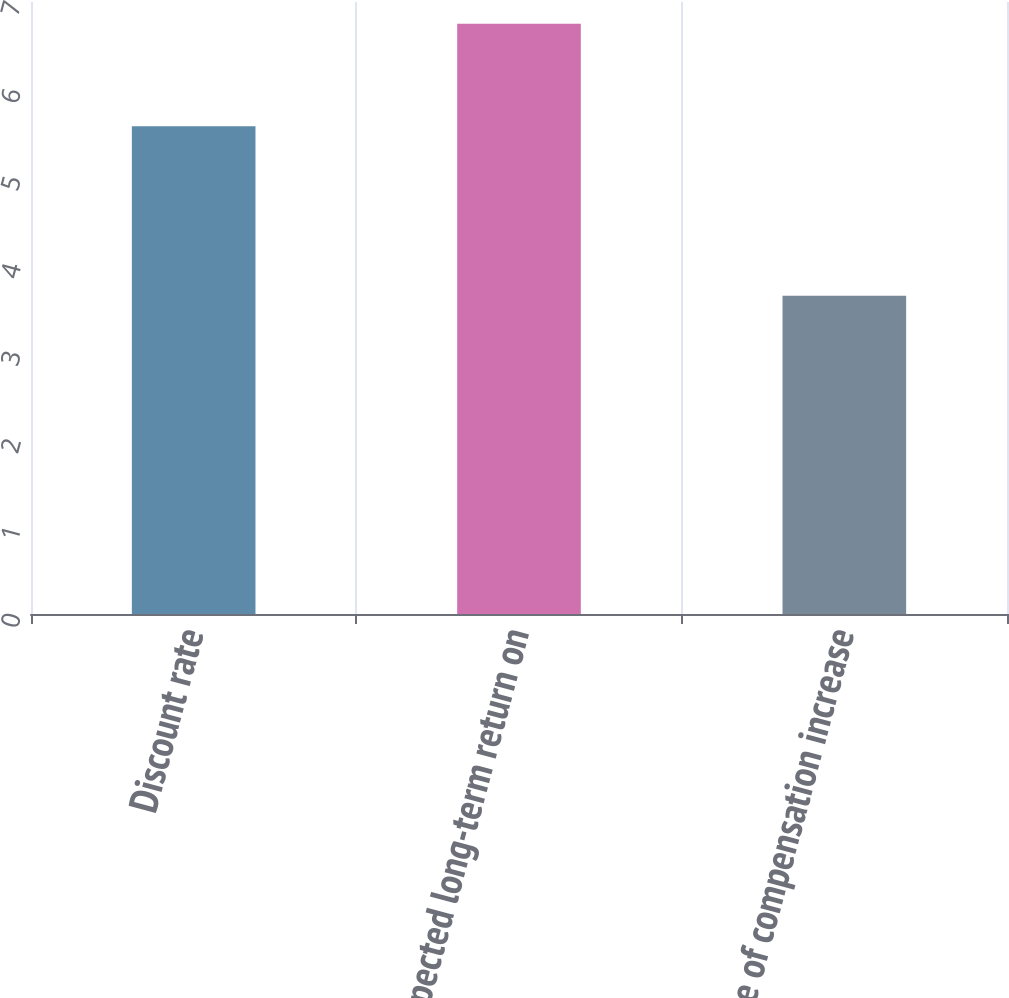<chart> <loc_0><loc_0><loc_500><loc_500><bar_chart><fcel>Discount rate<fcel>Expected long-term return on<fcel>Rate of compensation increase<nl><fcel>5.58<fcel>6.75<fcel>3.64<nl></chart> 